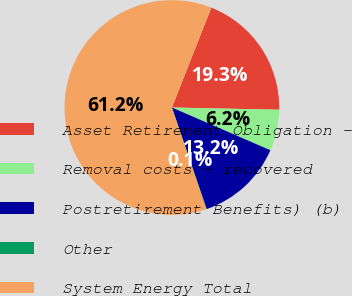Convert chart to OTSL. <chart><loc_0><loc_0><loc_500><loc_500><pie_chart><fcel>Asset Retirement Obligation -<fcel>Removal costs - recovered<fcel>Postretirement Benefits) (b)<fcel>Other<fcel>System Energy Total<nl><fcel>19.34%<fcel>6.18%<fcel>13.23%<fcel>0.07%<fcel>61.17%<nl></chart> 